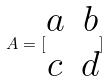Convert formula to latex. <formula><loc_0><loc_0><loc_500><loc_500>A = [ \begin{matrix} a & b \\ c & d \end{matrix} ]</formula> 